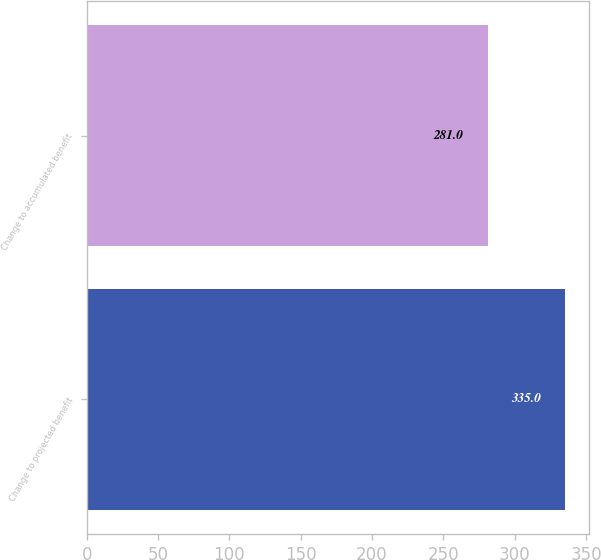Convert chart to OTSL. <chart><loc_0><loc_0><loc_500><loc_500><bar_chart><fcel>Change to projected benefit<fcel>Change to accumulated benefit<nl><fcel>335<fcel>281<nl></chart> 